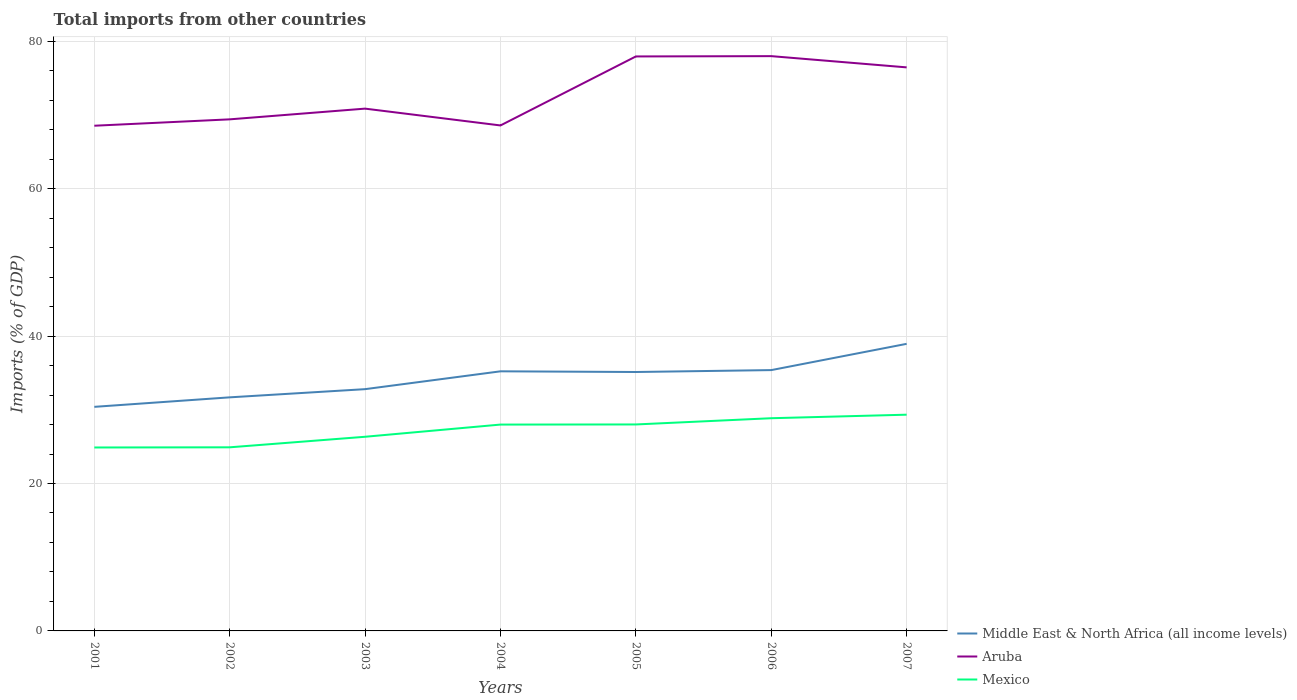How many different coloured lines are there?
Give a very brief answer. 3. Is the number of lines equal to the number of legend labels?
Your response must be concise. Yes. Across all years, what is the maximum total imports in Middle East & North Africa (all income levels)?
Your response must be concise. 30.4. What is the total total imports in Aruba in the graph?
Your answer should be very brief. -5.6. What is the difference between the highest and the second highest total imports in Aruba?
Provide a short and direct response. 9.44. What is the difference between the highest and the lowest total imports in Aruba?
Give a very brief answer. 3. Are the values on the major ticks of Y-axis written in scientific E-notation?
Your response must be concise. No. Does the graph contain any zero values?
Give a very brief answer. No. What is the title of the graph?
Your answer should be compact. Total imports from other countries. What is the label or title of the X-axis?
Ensure brevity in your answer.  Years. What is the label or title of the Y-axis?
Your answer should be very brief. Imports (% of GDP). What is the Imports (% of GDP) of Middle East & North Africa (all income levels) in 2001?
Give a very brief answer. 30.4. What is the Imports (% of GDP) of Aruba in 2001?
Your answer should be very brief. 68.53. What is the Imports (% of GDP) of Mexico in 2001?
Offer a very short reply. 24.88. What is the Imports (% of GDP) of Middle East & North Africa (all income levels) in 2002?
Your answer should be very brief. 31.69. What is the Imports (% of GDP) in Aruba in 2002?
Offer a terse response. 69.4. What is the Imports (% of GDP) in Mexico in 2002?
Your answer should be very brief. 24.91. What is the Imports (% of GDP) of Middle East & North Africa (all income levels) in 2003?
Provide a succinct answer. 32.8. What is the Imports (% of GDP) in Aruba in 2003?
Offer a terse response. 70.85. What is the Imports (% of GDP) of Mexico in 2003?
Offer a terse response. 26.34. What is the Imports (% of GDP) in Middle East & North Africa (all income levels) in 2004?
Your answer should be very brief. 35.22. What is the Imports (% of GDP) in Aruba in 2004?
Give a very brief answer. 68.57. What is the Imports (% of GDP) in Mexico in 2004?
Offer a very short reply. 27.99. What is the Imports (% of GDP) in Middle East & North Africa (all income levels) in 2005?
Your response must be concise. 35.13. What is the Imports (% of GDP) in Aruba in 2005?
Your response must be concise. 77.93. What is the Imports (% of GDP) in Mexico in 2005?
Keep it short and to the point. 28.01. What is the Imports (% of GDP) of Middle East & North Africa (all income levels) in 2006?
Keep it short and to the point. 35.38. What is the Imports (% of GDP) in Aruba in 2006?
Offer a terse response. 77.97. What is the Imports (% of GDP) of Mexico in 2006?
Provide a short and direct response. 28.85. What is the Imports (% of GDP) of Middle East & North Africa (all income levels) in 2007?
Provide a succinct answer. 38.95. What is the Imports (% of GDP) of Aruba in 2007?
Your response must be concise. 76.45. What is the Imports (% of GDP) of Mexico in 2007?
Provide a succinct answer. 29.33. Across all years, what is the maximum Imports (% of GDP) of Middle East & North Africa (all income levels)?
Give a very brief answer. 38.95. Across all years, what is the maximum Imports (% of GDP) of Aruba?
Provide a short and direct response. 77.97. Across all years, what is the maximum Imports (% of GDP) of Mexico?
Keep it short and to the point. 29.33. Across all years, what is the minimum Imports (% of GDP) of Middle East & North Africa (all income levels)?
Offer a terse response. 30.4. Across all years, what is the minimum Imports (% of GDP) in Aruba?
Your answer should be compact. 68.53. Across all years, what is the minimum Imports (% of GDP) of Mexico?
Your answer should be compact. 24.88. What is the total Imports (% of GDP) of Middle East & North Africa (all income levels) in the graph?
Provide a succinct answer. 239.55. What is the total Imports (% of GDP) of Aruba in the graph?
Give a very brief answer. 509.72. What is the total Imports (% of GDP) of Mexico in the graph?
Make the answer very short. 190.32. What is the difference between the Imports (% of GDP) in Middle East & North Africa (all income levels) in 2001 and that in 2002?
Provide a succinct answer. -1.29. What is the difference between the Imports (% of GDP) in Aruba in 2001 and that in 2002?
Ensure brevity in your answer.  -0.87. What is the difference between the Imports (% of GDP) of Mexico in 2001 and that in 2002?
Offer a very short reply. -0.02. What is the difference between the Imports (% of GDP) of Middle East & North Africa (all income levels) in 2001 and that in 2003?
Provide a succinct answer. -2.4. What is the difference between the Imports (% of GDP) of Aruba in 2001 and that in 2003?
Keep it short and to the point. -2.32. What is the difference between the Imports (% of GDP) in Mexico in 2001 and that in 2003?
Keep it short and to the point. -1.46. What is the difference between the Imports (% of GDP) of Middle East & North Africa (all income levels) in 2001 and that in 2004?
Offer a very short reply. -4.82. What is the difference between the Imports (% of GDP) in Aruba in 2001 and that in 2004?
Ensure brevity in your answer.  -0.04. What is the difference between the Imports (% of GDP) in Mexico in 2001 and that in 2004?
Keep it short and to the point. -3.11. What is the difference between the Imports (% of GDP) in Middle East & North Africa (all income levels) in 2001 and that in 2005?
Your answer should be very brief. -4.73. What is the difference between the Imports (% of GDP) in Aruba in 2001 and that in 2005?
Your response must be concise. -9.4. What is the difference between the Imports (% of GDP) in Mexico in 2001 and that in 2005?
Provide a succinct answer. -3.12. What is the difference between the Imports (% of GDP) in Middle East & North Africa (all income levels) in 2001 and that in 2006?
Keep it short and to the point. -4.99. What is the difference between the Imports (% of GDP) of Aruba in 2001 and that in 2006?
Offer a terse response. -9.44. What is the difference between the Imports (% of GDP) in Mexico in 2001 and that in 2006?
Give a very brief answer. -3.97. What is the difference between the Imports (% of GDP) of Middle East & North Africa (all income levels) in 2001 and that in 2007?
Provide a succinct answer. -8.55. What is the difference between the Imports (% of GDP) in Aruba in 2001 and that in 2007?
Provide a short and direct response. -7.92. What is the difference between the Imports (% of GDP) of Mexico in 2001 and that in 2007?
Ensure brevity in your answer.  -4.45. What is the difference between the Imports (% of GDP) in Middle East & North Africa (all income levels) in 2002 and that in 2003?
Provide a short and direct response. -1.11. What is the difference between the Imports (% of GDP) of Aruba in 2002 and that in 2003?
Provide a short and direct response. -1.45. What is the difference between the Imports (% of GDP) of Mexico in 2002 and that in 2003?
Your response must be concise. -1.43. What is the difference between the Imports (% of GDP) of Middle East & North Africa (all income levels) in 2002 and that in 2004?
Offer a terse response. -3.53. What is the difference between the Imports (% of GDP) of Aruba in 2002 and that in 2004?
Give a very brief answer. 0.83. What is the difference between the Imports (% of GDP) of Mexico in 2002 and that in 2004?
Your answer should be compact. -3.08. What is the difference between the Imports (% of GDP) in Middle East & North Africa (all income levels) in 2002 and that in 2005?
Provide a succinct answer. -3.44. What is the difference between the Imports (% of GDP) of Aruba in 2002 and that in 2005?
Your answer should be compact. -8.53. What is the difference between the Imports (% of GDP) of Mexico in 2002 and that in 2005?
Provide a short and direct response. -3.1. What is the difference between the Imports (% of GDP) of Middle East & North Africa (all income levels) in 2002 and that in 2006?
Your answer should be very brief. -3.7. What is the difference between the Imports (% of GDP) of Aruba in 2002 and that in 2006?
Make the answer very short. -8.57. What is the difference between the Imports (% of GDP) in Mexico in 2002 and that in 2006?
Your response must be concise. -3.95. What is the difference between the Imports (% of GDP) of Middle East & North Africa (all income levels) in 2002 and that in 2007?
Your answer should be very brief. -7.26. What is the difference between the Imports (% of GDP) of Aruba in 2002 and that in 2007?
Provide a succinct answer. -7.05. What is the difference between the Imports (% of GDP) in Mexico in 2002 and that in 2007?
Your answer should be compact. -4.43. What is the difference between the Imports (% of GDP) of Middle East & North Africa (all income levels) in 2003 and that in 2004?
Offer a very short reply. -2.42. What is the difference between the Imports (% of GDP) in Aruba in 2003 and that in 2004?
Offer a very short reply. 2.28. What is the difference between the Imports (% of GDP) in Mexico in 2003 and that in 2004?
Ensure brevity in your answer.  -1.65. What is the difference between the Imports (% of GDP) in Middle East & North Africa (all income levels) in 2003 and that in 2005?
Provide a short and direct response. -2.33. What is the difference between the Imports (% of GDP) of Aruba in 2003 and that in 2005?
Your answer should be compact. -7.08. What is the difference between the Imports (% of GDP) of Mexico in 2003 and that in 2005?
Your response must be concise. -1.67. What is the difference between the Imports (% of GDP) in Middle East & North Africa (all income levels) in 2003 and that in 2006?
Offer a very short reply. -2.58. What is the difference between the Imports (% of GDP) in Aruba in 2003 and that in 2006?
Your answer should be very brief. -7.12. What is the difference between the Imports (% of GDP) of Mexico in 2003 and that in 2006?
Your response must be concise. -2.51. What is the difference between the Imports (% of GDP) of Middle East & North Africa (all income levels) in 2003 and that in 2007?
Your answer should be compact. -6.15. What is the difference between the Imports (% of GDP) in Aruba in 2003 and that in 2007?
Provide a succinct answer. -5.6. What is the difference between the Imports (% of GDP) of Mexico in 2003 and that in 2007?
Keep it short and to the point. -2.99. What is the difference between the Imports (% of GDP) of Middle East & North Africa (all income levels) in 2004 and that in 2005?
Your answer should be compact. 0.09. What is the difference between the Imports (% of GDP) of Aruba in 2004 and that in 2005?
Offer a very short reply. -9.36. What is the difference between the Imports (% of GDP) of Mexico in 2004 and that in 2005?
Your response must be concise. -0.02. What is the difference between the Imports (% of GDP) of Middle East & North Africa (all income levels) in 2004 and that in 2006?
Provide a succinct answer. -0.17. What is the difference between the Imports (% of GDP) of Aruba in 2004 and that in 2006?
Provide a short and direct response. -9.4. What is the difference between the Imports (% of GDP) of Mexico in 2004 and that in 2006?
Provide a short and direct response. -0.86. What is the difference between the Imports (% of GDP) of Middle East & North Africa (all income levels) in 2004 and that in 2007?
Provide a succinct answer. -3.73. What is the difference between the Imports (% of GDP) in Aruba in 2004 and that in 2007?
Offer a terse response. -7.88. What is the difference between the Imports (% of GDP) of Mexico in 2004 and that in 2007?
Keep it short and to the point. -1.34. What is the difference between the Imports (% of GDP) in Middle East & North Africa (all income levels) in 2005 and that in 2006?
Give a very brief answer. -0.26. What is the difference between the Imports (% of GDP) in Aruba in 2005 and that in 2006?
Your response must be concise. -0.04. What is the difference between the Imports (% of GDP) in Mexico in 2005 and that in 2006?
Give a very brief answer. -0.85. What is the difference between the Imports (% of GDP) of Middle East & North Africa (all income levels) in 2005 and that in 2007?
Your response must be concise. -3.82. What is the difference between the Imports (% of GDP) of Aruba in 2005 and that in 2007?
Offer a very short reply. 1.48. What is the difference between the Imports (% of GDP) of Mexico in 2005 and that in 2007?
Your answer should be compact. -1.33. What is the difference between the Imports (% of GDP) of Middle East & North Africa (all income levels) in 2006 and that in 2007?
Make the answer very short. -3.56. What is the difference between the Imports (% of GDP) in Aruba in 2006 and that in 2007?
Your answer should be very brief. 1.52. What is the difference between the Imports (% of GDP) of Mexico in 2006 and that in 2007?
Provide a short and direct response. -0.48. What is the difference between the Imports (% of GDP) of Middle East & North Africa (all income levels) in 2001 and the Imports (% of GDP) of Aruba in 2002?
Keep it short and to the point. -39. What is the difference between the Imports (% of GDP) in Middle East & North Africa (all income levels) in 2001 and the Imports (% of GDP) in Mexico in 2002?
Your answer should be compact. 5.49. What is the difference between the Imports (% of GDP) of Aruba in 2001 and the Imports (% of GDP) of Mexico in 2002?
Keep it short and to the point. 43.63. What is the difference between the Imports (% of GDP) of Middle East & North Africa (all income levels) in 2001 and the Imports (% of GDP) of Aruba in 2003?
Offer a very short reply. -40.46. What is the difference between the Imports (% of GDP) of Middle East & North Africa (all income levels) in 2001 and the Imports (% of GDP) of Mexico in 2003?
Make the answer very short. 4.06. What is the difference between the Imports (% of GDP) of Aruba in 2001 and the Imports (% of GDP) of Mexico in 2003?
Ensure brevity in your answer.  42.19. What is the difference between the Imports (% of GDP) in Middle East & North Africa (all income levels) in 2001 and the Imports (% of GDP) in Aruba in 2004?
Keep it short and to the point. -38.18. What is the difference between the Imports (% of GDP) of Middle East & North Africa (all income levels) in 2001 and the Imports (% of GDP) of Mexico in 2004?
Offer a terse response. 2.4. What is the difference between the Imports (% of GDP) of Aruba in 2001 and the Imports (% of GDP) of Mexico in 2004?
Give a very brief answer. 40.54. What is the difference between the Imports (% of GDP) of Middle East & North Africa (all income levels) in 2001 and the Imports (% of GDP) of Aruba in 2005?
Make the answer very short. -47.54. What is the difference between the Imports (% of GDP) in Middle East & North Africa (all income levels) in 2001 and the Imports (% of GDP) in Mexico in 2005?
Make the answer very short. 2.39. What is the difference between the Imports (% of GDP) in Aruba in 2001 and the Imports (% of GDP) in Mexico in 2005?
Provide a short and direct response. 40.53. What is the difference between the Imports (% of GDP) of Middle East & North Africa (all income levels) in 2001 and the Imports (% of GDP) of Aruba in 2006?
Provide a short and direct response. -47.58. What is the difference between the Imports (% of GDP) of Middle East & North Africa (all income levels) in 2001 and the Imports (% of GDP) of Mexico in 2006?
Provide a short and direct response. 1.54. What is the difference between the Imports (% of GDP) of Aruba in 2001 and the Imports (% of GDP) of Mexico in 2006?
Ensure brevity in your answer.  39.68. What is the difference between the Imports (% of GDP) in Middle East & North Africa (all income levels) in 2001 and the Imports (% of GDP) in Aruba in 2007?
Your answer should be very brief. -46.05. What is the difference between the Imports (% of GDP) in Middle East & North Africa (all income levels) in 2001 and the Imports (% of GDP) in Mexico in 2007?
Ensure brevity in your answer.  1.06. What is the difference between the Imports (% of GDP) in Aruba in 2001 and the Imports (% of GDP) in Mexico in 2007?
Give a very brief answer. 39.2. What is the difference between the Imports (% of GDP) in Middle East & North Africa (all income levels) in 2002 and the Imports (% of GDP) in Aruba in 2003?
Provide a succinct answer. -39.17. What is the difference between the Imports (% of GDP) of Middle East & North Africa (all income levels) in 2002 and the Imports (% of GDP) of Mexico in 2003?
Make the answer very short. 5.35. What is the difference between the Imports (% of GDP) of Aruba in 2002 and the Imports (% of GDP) of Mexico in 2003?
Make the answer very short. 43.06. What is the difference between the Imports (% of GDP) in Middle East & North Africa (all income levels) in 2002 and the Imports (% of GDP) in Aruba in 2004?
Keep it short and to the point. -36.89. What is the difference between the Imports (% of GDP) in Middle East & North Africa (all income levels) in 2002 and the Imports (% of GDP) in Mexico in 2004?
Your response must be concise. 3.69. What is the difference between the Imports (% of GDP) of Aruba in 2002 and the Imports (% of GDP) of Mexico in 2004?
Provide a succinct answer. 41.41. What is the difference between the Imports (% of GDP) of Middle East & North Africa (all income levels) in 2002 and the Imports (% of GDP) of Aruba in 2005?
Ensure brevity in your answer.  -46.25. What is the difference between the Imports (% of GDP) in Middle East & North Africa (all income levels) in 2002 and the Imports (% of GDP) in Mexico in 2005?
Offer a terse response. 3.68. What is the difference between the Imports (% of GDP) of Aruba in 2002 and the Imports (% of GDP) of Mexico in 2005?
Your answer should be compact. 41.39. What is the difference between the Imports (% of GDP) of Middle East & North Africa (all income levels) in 2002 and the Imports (% of GDP) of Aruba in 2006?
Your response must be concise. -46.29. What is the difference between the Imports (% of GDP) of Middle East & North Africa (all income levels) in 2002 and the Imports (% of GDP) of Mexico in 2006?
Offer a terse response. 2.83. What is the difference between the Imports (% of GDP) in Aruba in 2002 and the Imports (% of GDP) in Mexico in 2006?
Give a very brief answer. 40.55. What is the difference between the Imports (% of GDP) of Middle East & North Africa (all income levels) in 2002 and the Imports (% of GDP) of Aruba in 2007?
Ensure brevity in your answer.  -44.76. What is the difference between the Imports (% of GDP) of Middle East & North Africa (all income levels) in 2002 and the Imports (% of GDP) of Mexico in 2007?
Make the answer very short. 2.35. What is the difference between the Imports (% of GDP) of Aruba in 2002 and the Imports (% of GDP) of Mexico in 2007?
Give a very brief answer. 40.07. What is the difference between the Imports (% of GDP) of Middle East & North Africa (all income levels) in 2003 and the Imports (% of GDP) of Aruba in 2004?
Make the answer very short. -35.77. What is the difference between the Imports (% of GDP) of Middle East & North Africa (all income levels) in 2003 and the Imports (% of GDP) of Mexico in 2004?
Offer a very short reply. 4.81. What is the difference between the Imports (% of GDP) of Aruba in 2003 and the Imports (% of GDP) of Mexico in 2004?
Make the answer very short. 42.86. What is the difference between the Imports (% of GDP) in Middle East & North Africa (all income levels) in 2003 and the Imports (% of GDP) in Aruba in 2005?
Give a very brief answer. -45.13. What is the difference between the Imports (% of GDP) of Middle East & North Africa (all income levels) in 2003 and the Imports (% of GDP) of Mexico in 2005?
Offer a very short reply. 4.79. What is the difference between the Imports (% of GDP) in Aruba in 2003 and the Imports (% of GDP) in Mexico in 2005?
Offer a terse response. 42.84. What is the difference between the Imports (% of GDP) in Middle East & North Africa (all income levels) in 2003 and the Imports (% of GDP) in Aruba in 2006?
Your answer should be very brief. -45.18. What is the difference between the Imports (% of GDP) in Middle East & North Africa (all income levels) in 2003 and the Imports (% of GDP) in Mexico in 2006?
Offer a terse response. 3.94. What is the difference between the Imports (% of GDP) of Aruba in 2003 and the Imports (% of GDP) of Mexico in 2006?
Provide a succinct answer. 42. What is the difference between the Imports (% of GDP) in Middle East & North Africa (all income levels) in 2003 and the Imports (% of GDP) in Aruba in 2007?
Give a very brief answer. -43.65. What is the difference between the Imports (% of GDP) in Middle East & North Africa (all income levels) in 2003 and the Imports (% of GDP) in Mexico in 2007?
Keep it short and to the point. 3.46. What is the difference between the Imports (% of GDP) in Aruba in 2003 and the Imports (% of GDP) in Mexico in 2007?
Offer a very short reply. 41.52. What is the difference between the Imports (% of GDP) of Middle East & North Africa (all income levels) in 2004 and the Imports (% of GDP) of Aruba in 2005?
Offer a very short reply. -42.72. What is the difference between the Imports (% of GDP) of Middle East & North Africa (all income levels) in 2004 and the Imports (% of GDP) of Mexico in 2005?
Provide a succinct answer. 7.21. What is the difference between the Imports (% of GDP) in Aruba in 2004 and the Imports (% of GDP) in Mexico in 2005?
Your answer should be very brief. 40.56. What is the difference between the Imports (% of GDP) of Middle East & North Africa (all income levels) in 2004 and the Imports (% of GDP) of Aruba in 2006?
Your answer should be very brief. -42.76. What is the difference between the Imports (% of GDP) in Middle East & North Africa (all income levels) in 2004 and the Imports (% of GDP) in Mexico in 2006?
Provide a succinct answer. 6.36. What is the difference between the Imports (% of GDP) of Aruba in 2004 and the Imports (% of GDP) of Mexico in 2006?
Your response must be concise. 39.72. What is the difference between the Imports (% of GDP) in Middle East & North Africa (all income levels) in 2004 and the Imports (% of GDP) in Aruba in 2007?
Provide a short and direct response. -41.23. What is the difference between the Imports (% of GDP) in Middle East & North Africa (all income levels) in 2004 and the Imports (% of GDP) in Mexico in 2007?
Keep it short and to the point. 5.88. What is the difference between the Imports (% of GDP) in Aruba in 2004 and the Imports (% of GDP) in Mexico in 2007?
Keep it short and to the point. 39.24. What is the difference between the Imports (% of GDP) in Middle East & North Africa (all income levels) in 2005 and the Imports (% of GDP) in Aruba in 2006?
Your answer should be compact. -42.85. What is the difference between the Imports (% of GDP) in Middle East & North Africa (all income levels) in 2005 and the Imports (% of GDP) in Mexico in 2006?
Your answer should be very brief. 6.27. What is the difference between the Imports (% of GDP) in Aruba in 2005 and the Imports (% of GDP) in Mexico in 2006?
Your response must be concise. 49.08. What is the difference between the Imports (% of GDP) of Middle East & North Africa (all income levels) in 2005 and the Imports (% of GDP) of Aruba in 2007?
Offer a very short reply. -41.33. What is the difference between the Imports (% of GDP) of Middle East & North Africa (all income levels) in 2005 and the Imports (% of GDP) of Mexico in 2007?
Ensure brevity in your answer.  5.79. What is the difference between the Imports (% of GDP) in Aruba in 2005 and the Imports (% of GDP) in Mexico in 2007?
Your answer should be compact. 48.6. What is the difference between the Imports (% of GDP) of Middle East & North Africa (all income levels) in 2006 and the Imports (% of GDP) of Aruba in 2007?
Your response must be concise. -41.07. What is the difference between the Imports (% of GDP) of Middle East & North Africa (all income levels) in 2006 and the Imports (% of GDP) of Mexico in 2007?
Your answer should be compact. 6.05. What is the difference between the Imports (% of GDP) in Aruba in 2006 and the Imports (% of GDP) in Mexico in 2007?
Your answer should be compact. 48.64. What is the average Imports (% of GDP) of Middle East & North Africa (all income levels) per year?
Your answer should be very brief. 34.22. What is the average Imports (% of GDP) of Aruba per year?
Provide a succinct answer. 72.82. What is the average Imports (% of GDP) of Mexico per year?
Ensure brevity in your answer.  27.19. In the year 2001, what is the difference between the Imports (% of GDP) in Middle East & North Africa (all income levels) and Imports (% of GDP) in Aruba?
Your response must be concise. -38.14. In the year 2001, what is the difference between the Imports (% of GDP) of Middle East & North Africa (all income levels) and Imports (% of GDP) of Mexico?
Your answer should be compact. 5.51. In the year 2001, what is the difference between the Imports (% of GDP) in Aruba and Imports (% of GDP) in Mexico?
Provide a succinct answer. 43.65. In the year 2002, what is the difference between the Imports (% of GDP) of Middle East & North Africa (all income levels) and Imports (% of GDP) of Aruba?
Provide a succinct answer. -37.71. In the year 2002, what is the difference between the Imports (% of GDP) of Middle East & North Africa (all income levels) and Imports (% of GDP) of Mexico?
Keep it short and to the point. 6.78. In the year 2002, what is the difference between the Imports (% of GDP) of Aruba and Imports (% of GDP) of Mexico?
Provide a short and direct response. 44.49. In the year 2003, what is the difference between the Imports (% of GDP) of Middle East & North Africa (all income levels) and Imports (% of GDP) of Aruba?
Provide a short and direct response. -38.06. In the year 2003, what is the difference between the Imports (% of GDP) of Middle East & North Africa (all income levels) and Imports (% of GDP) of Mexico?
Ensure brevity in your answer.  6.46. In the year 2003, what is the difference between the Imports (% of GDP) of Aruba and Imports (% of GDP) of Mexico?
Your response must be concise. 44.51. In the year 2004, what is the difference between the Imports (% of GDP) in Middle East & North Africa (all income levels) and Imports (% of GDP) in Aruba?
Give a very brief answer. -33.36. In the year 2004, what is the difference between the Imports (% of GDP) of Middle East & North Africa (all income levels) and Imports (% of GDP) of Mexico?
Give a very brief answer. 7.22. In the year 2004, what is the difference between the Imports (% of GDP) in Aruba and Imports (% of GDP) in Mexico?
Your answer should be compact. 40.58. In the year 2005, what is the difference between the Imports (% of GDP) in Middle East & North Africa (all income levels) and Imports (% of GDP) in Aruba?
Your answer should be compact. -42.81. In the year 2005, what is the difference between the Imports (% of GDP) in Middle East & North Africa (all income levels) and Imports (% of GDP) in Mexico?
Ensure brevity in your answer.  7.12. In the year 2005, what is the difference between the Imports (% of GDP) in Aruba and Imports (% of GDP) in Mexico?
Give a very brief answer. 49.92. In the year 2006, what is the difference between the Imports (% of GDP) of Middle East & North Africa (all income levels) and Imports (% of GDP) of Aruba?
Give a very brief answer. -42.59. In the year 2006, what is the difference between the Imports (% of GDP) of Middle East & North Africa (all income levels) and Imports (% of GDP) of Mexico?
Give a very brief answer. 6.53. In the year 2006, what is the difference between the Imports (% of GDP) of Aruba and Imports (% of GDP) of Mexico?
Provide a short and direct response. 49.12. In the year 2007, what is the difference between the Imports (% of GDP) in Middle East & North Africa (all income levels) and Imports (% of GDP) in Aruba?
Your answer should be compact. -37.5. In the year 2007, what is the difference between the Imports (% of GDP) in Middle East & North Africa (all income levels) and Imports (% of GDP) in Mexico?
Ensure brevity in your answer.  9.61. In the year 2007, what is the difference between the Imports (% of GDP) in Aruba and Imports (% of GDP) in Mexico?
Your response must be concise. 47.12. What is the ratio of the Imports (% of GDP) of Middle East & North Africa (all income levels) in 2001 to that in 2002?
Ensure brevity in your answer.  0.96. What is the ratio of the Imports (% of GDP) in Aruba in 2001 to that in 2002?
Your response must be concise. 0.99. What is the ratio of the Imports (% of GDP) in Mexico in 2001 to that in 2002?
Your answer should be compact. 1. What is the ratio of the Imports (% of GDP) in Middle East & North Africa (all income levels) in 2001 to that in 2003?
Your answer should be compact. 0.93. What is the ratio of the Imports (% of GDP) of Aruba in 2001 to that in 2003?
Ensure brevity in your answer.  0.97. What is the ratio of the Imports (% of GDP) of Mexico in 2001 to that in 2003?
Give a very brief answer. 0.94. What is the ratio of the Imports (% of GDP) in Middle East & North Africa (all income levels) in 2001 to that in 2004?
Your response must be concise. 0.86. What is the ratio of the Imports (% of GDP) of Aruba in 2001 to that in 2004?
Provide a succinct answer. 1. What is the ratio of the Imports (% of GDP) of Middle East & North Africa (all income levels) in 2001 to that in 2005?
Provide a succinct answer. 0.87. What is the ratio of the Imports (% of GDP) of Aruba in 2001 to that in 2005?
Your answer should be compact. 0.88. What is the ratio of the Imports (% of GDP) of Mexico in 2001 to that in 2005?
Offer a very short reply. 0.89. What is the ratio of the Imports (% of GDP) in Middle East & North Africa (all income levels) in 2001 to that in 2006?
Your response must be concise. 0.86. What is the ratio of the Imports (% of GDP) of Aruba in 2001 to that in 2006?
Make the answer very short. 0.88. What is the ratio of the Imports (% of GDP) of Mexico in 2001 to that in 2006?
Ensure brevity in your answer.  0.86. What is the ratio of the Imports (% of GDP) in Middle East & North Africa (all income levels) in 2001 to that in 2007?
Ensure brevity in your answer.  0.78. What is the ratio of the Imports (% of GDP) of Aruba in 2001 to that in 2007?
Give a very brief answer. 0.9. What is the ratio of the Imports (% of GDP) in Mexico in 2001 to that in 2007?
Your answer should be very brief. 0.85. What is the ratio of the Imports (% of GDP) in Middle East & North Africa (all income levels) in 2002 to that in 2003?
Give a very brief answer. 0.97. What is the ratio of the Imports (% of GDP) of Aruba in 2002 to that in 2003?
Provide a succinct answer. 0.98. What is the ratio of the Imports (% of GDP) in Mexico in 2002 to that in 2003?
Your answer should be very brief. 0.95. What is the ratio of the Imports (% of GDP) of Middle East & North Africa (all income levels) in 2002 to that in 2004?
Keep it short and to the point. 0.9. What is the ratio of the Imports (% of GDP) in Aruba in 2002 to that in 2004?
Your response must be concise. 1.01. What is the ratio of the Imports (% of GDP) of Mexico in 2002 to that in 2004?
Your answer should be very brief. 0.89. What is the ratio of the Imports (% of GDP) of Middle East & North Africa (all income levels) in 2002 to that in 2005?
Offer a terse response. 0.9. What is the ratio of the Imports (% of GDP) of Aruba in 2002 to that in 2005?
Offer a very short reply. 0.89. What is the ratio of the Imports (% of GDP) of Mexico in 2002 to that in 2005?
Ensure brevity in your answer.  0.89. What is the ratio of the Imports (% of GDP) of Middle East & North Africa (all income levels) in 2002 to that in 2006?
Provide a succinct answer. 0.9. What is the ratio of the Imports (% of GDP) of Aruba in 2002 to that in 2006?
Offer a terse response. 0.89. What is the ratio of the Imports (% of GDP) in Mexico in 2002 to that in 2006?
Offer a terse response. 0.86. What is the ratio of the Imports (% of GDP) in Middle East & North Africa (all income levels) in 2002 to that in 2007?
Provide a succinct answer. 0.81. What is the ratio of the Imports (% of GDP) of Aruba in 2002 to that in 2007?
Offer a very short reply. 0.91. What is the ratio of the Imports (% of GDP) in Mexico in 2002 to that in 2007?
Offer a very short reply. 0.85. What is the ratio of the Imports (% of GDP) of Middle East & North Africa (all income levels) in 2003 to that in 2004?
Offer a terse response. 0.93. What is the ratio of the Imports (% of GDP) in Aruba in 2003 to that in 2004?
Your answer should be very brief. 1.03. What is the ratio of the Imports (% of GDP) in Mexico in 2003 to that in 2004?
Ensure brevity in your answer.  0.94. What is the ratio of the Imports (% of GDP) in Middle East & North Africa (all income levels) in 2003 to that in 2005?
Make the answer very short. 0.93. What is the ratio of the Imports (% of GDP) in Aruba in 2003 to that in 2005?
Your answer should be compact. 0.91. What is the ratio of the Imports (% of GDP) in Mexico in 2003 to that in 2005?
Make the answer very short. 0.94. What is the ratio of the Imports (% of GDP) of Middle East & North Africa (all income levels) in 2003 to that in 2006?
Provide a succinct answer. 0.93. What is the ratio of the Imports (% of GDP) of Aruba in 2003 to that in 2006?
Your response must be concise. 0.91. What is the ratio of the Imports (% of GDP) in Mexico in 2003 to that in 2006?
Offer a terse response. 0.91. What is the ratio of the Imports (% of GDP) of Middle East & North Africa (all income levels) in 2003 to that in 2007?
Offer a very short reply. 0.84. What is the ratio of the Imports (% of GDP) of Aruba in 2003 to that in 2007?
Your answer should be compact. 0.93. What is the ratio of the Imports (% of GDP) in Mexico in 2003 to that in 2007?
Offer a terse response. 0.9. What is the ratio of the Imports (% of GDP) of Aruba in 2004 to that in 2005?
Keep it short and to the point. 0.88. What is the ratio of the Imports (% of GDP) in Mexico in 2004 to that in 2005?
Provide a short and direct response. 1. What is the ratio of the Imports (% of GDP) in Middle East & North Africa (all income levels) in 2004 to that in 2006?
Ensure brevity in your answer.  1. What is the ratio of the Imports (% of GDP) in Aruba in 2004 to that in 2006?
Your response must be concise. 0.88. What is the ratio of the Imports (% of GDP) in Mexico in 2004 to that in 2006?
Provide a short and direct response. 0.97. What is the ratio of the Imports (% of GDP) in Middle East & North Africa (all income levels) in 2004 to that in 2007?
Your answer should be very brief. 0.9. What is the ratio of the Imports (% of GDP) of Aruba in 2004 to that in 2007?
Keep it short and to the point. 0.9. What is the ratio of the Imports (% of GDP) of Mexico in 2004 to that in 2007?
Offer a terse response. 0.95. What is the ratio of the Imports (% of GDP) of Aruba in 2005 to that in 2006?
Your response must be concise. 1. What is the ratio of the Imports (% of GDP) in Mexico in 2005 to that in 2006?
Provide a short and direct response. 0.97. What is the ratio of the Imports (% of GDP) of Middle East & North Africa (all income levels) in 2005 to that in 2007?
Offer a very short reply. 0.9. What is the ratio of the Imports (% of GDP) in Aruba in 2005 to that in 2007?
Keep it short and to the point. 1.02. What is the ratio of the Imports (% of GDP) in Mexico in 2005 to that in 2007?
Keep it short and to the point. 0.95. What is the ratio of the Imports (% of GDP) in Middle East & North Africa (all income levels) in 2006 to that in 2007?
Offer a very short reply. 0.91. What is the ratio of the Imports (% of GDP) of Aruba in 2006 to that in 2007?
Offer a terse response. 1.02. What is the ratio of the Imports (% of GDP) of Mexico in 2006 to that in 2007?
Make the answer very short. 0.98. What is the difference between the highest and the second highest Imports (% of GDP) in Middle East & North Africa (all income levels)?
Your answer should be compact. 3.56. What is the difference between the highest and the second highest Imports (% of GDP) of Aruba?
Offer a terse response. 0.04. What is the difference between the highest and the second highest Imports (% of GDP) of Mexico?
Your answer should be very brief. 0.48. What is the difference between the highest and the lowest Imports (% of GDP) of Middle East & North Africa (all income levels)?
Offer a very short reply. 8.55. What is the difference between the highest and the lowest Imports (% of GDP) of Aruba?
Provide a succinct answer. 9.44. What is the difference between the highest and the lowest Imports (% of GDP) of Mexico?
Provide a short and direct response. 4.45. 